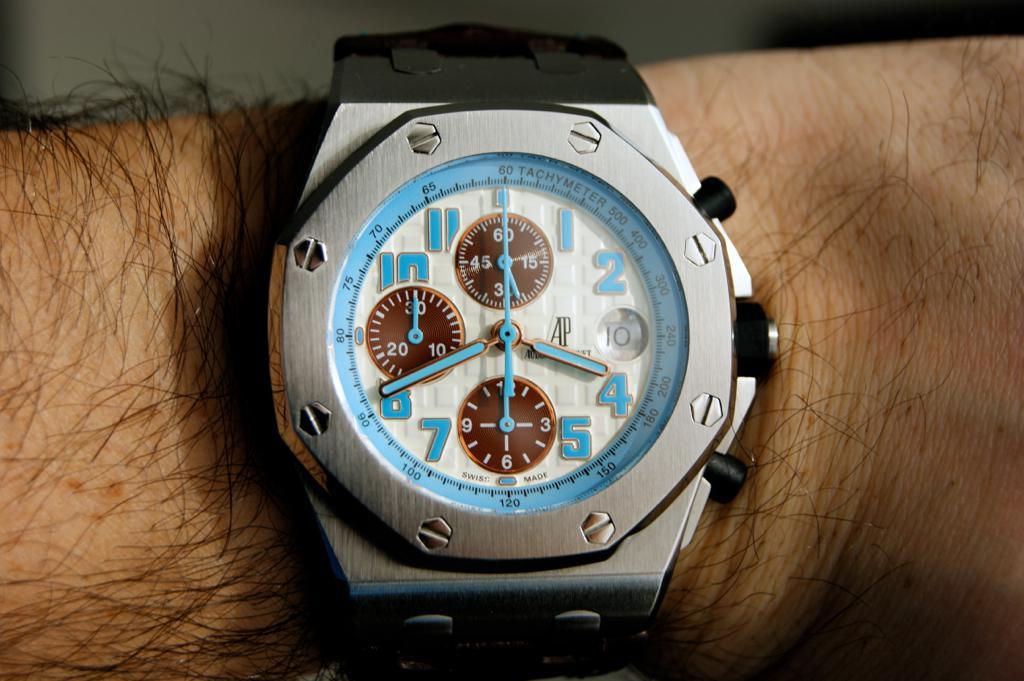What time does the watch say?
Your answer should be very brief. 3:41. 